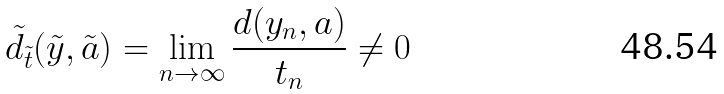<formula> <loc_0><loc_0><loc_500><loc_500>\tilde { d } _ { \tilde { t } } ( \tilde { y } , \tilde { a } ) = \lim _ { n \to \infty } \frac { d ( y _ { n } , a ) } { t _ { n } } \ne 0</formula> 